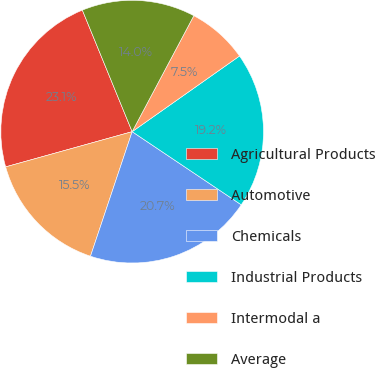Convert chart to OTSL. <chart><loc_0><loc_0><loc_500><loc_500><pie_chart><fcel>Agricultural Products<fcel>Automotive<fcel>Chemicals<fcel>Industrial Products<fcel>Intermodal a<fcel>Average<nl><fcel>23.13%<fcel>15.54%<fcel>20.74%<fcel>19.17%<fcel>7.45%<fcel>13.97%<nl></chart> 